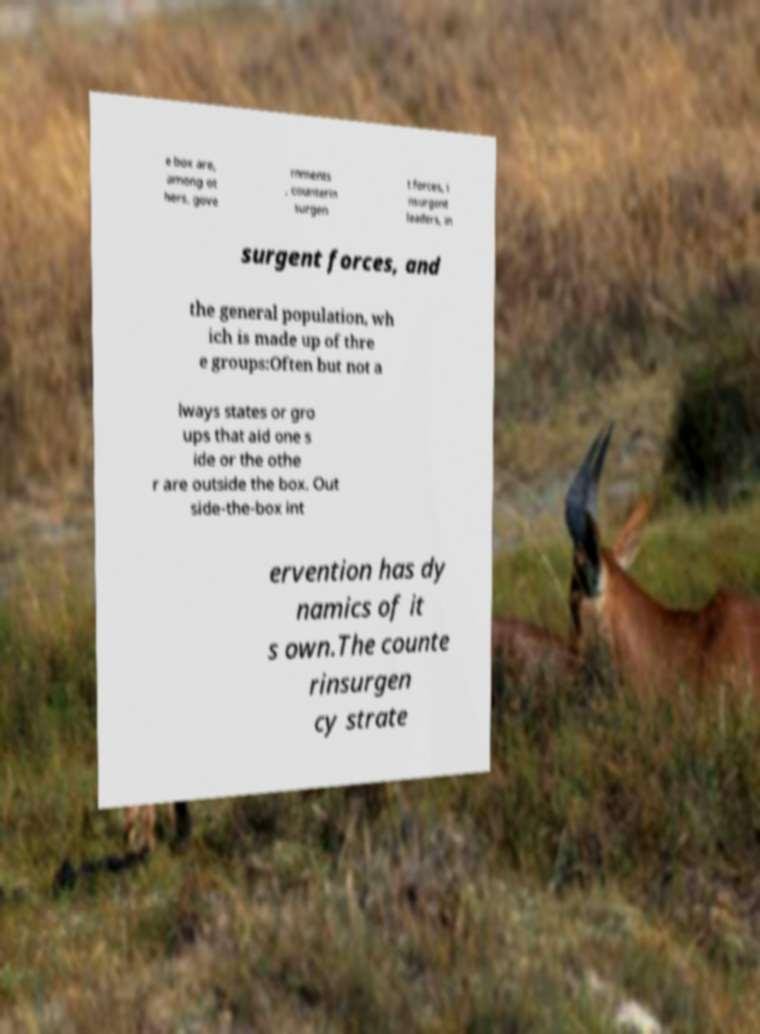What messages or text are displayed in this image? I need them in a readable, typed format. e box are, among ot hers, gove rnments , counterin surgen t forces, i nsurgent leaders, in surgent forces, and the general population, wh ich is made up of thre e groups:Often but not a lways states or gro ups that aid one s ide or the othe r are outside the box. Out side-the-box int ervention has dy namics of it s own.The counte rinsurgen cy strate 